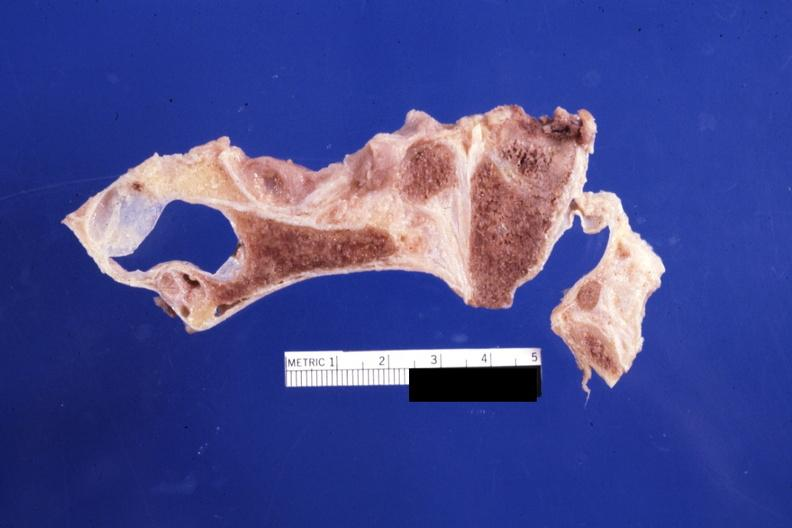does case of dic not bad photo show sagittal section of atlas vertebra and occipital bone foramen magnum stenosis case 31?
Answer the question using a single word or phrase. No 